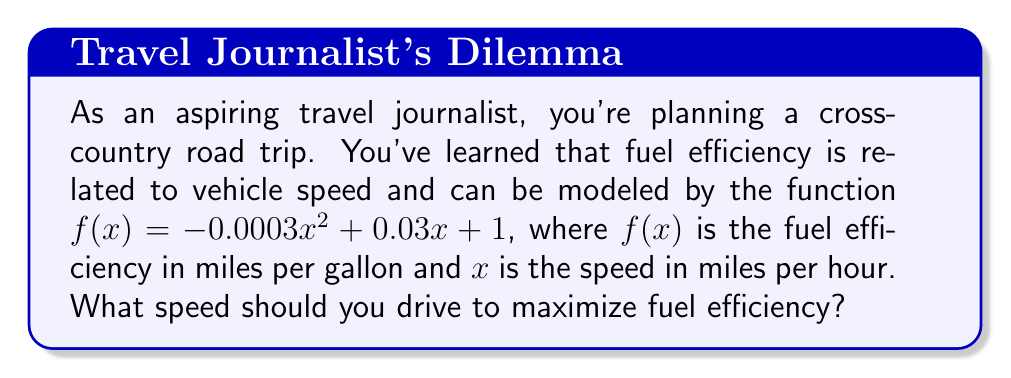Give your solution to this math problem. To find the speed that maximizes fuel efficiency, we need to find the maximum point of the given function. This can be done by finding the derivative of the function and setting it equal to zero.

1. Given function: $f(x) = -0.0003x^2 + 0.03x + 1$

2. Find the derivative:
   $f'(x) = -0.0006x + 0.03$

3. Set the derivative equal to zero and solve for x:
   $-0.0006x + 0.03 = 0$
   $-0.0006x = -0.03$
   $x = 50$

4. To confirm this is a maximum, we can check the second derivative:
   $f''(x) = -0.0006$
   Since $f''(x)$ is negative, the critical point at $x = 50$ is indeed a maximum.

5. Therefore, the speed that maximizes fuel efficiency is 50 miles per hour.
Answer: 50 mph 